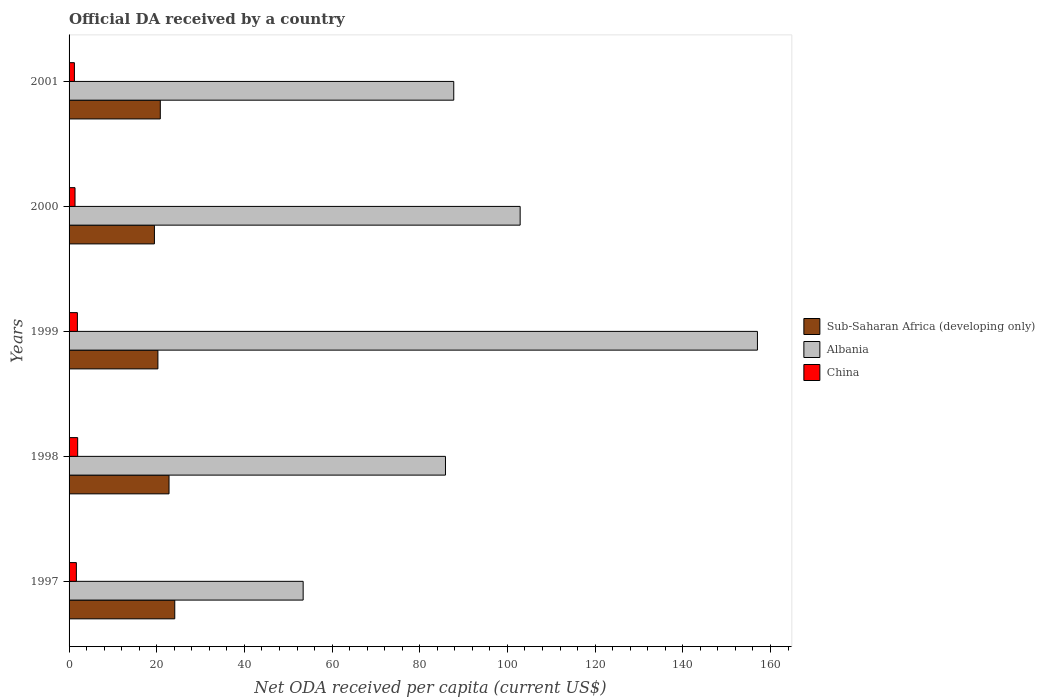How many different coloured bars are there?
Keep it short and to the point. 3. Are the number of bars per tick equal to the number of legend labels?
Make the answer very short. Yes. Are the number of bars on each tick of the Y-axis equal?
Ensure brevity in your answer.  Yes. How many bars are there on the 4th tick from the top?
Offer a terse response. 3. What is the label of the 1st group of bars from the top?
Your answer should be compact. 2001. What is the ODA received in in Sub-Saharan Africa (developing only) in 2000?
Offer a terse response. 19.47. Across all years, what is the maximum ODA received in in Albania?
Give a very brief answer. 157.02. Across all years, what is the minimum ODA received in in Albania?
Provide a short and direct response. 53.4. What is the total ODA received in in China in the graph?
Your answer should be compact. 8.1. What is the difference between the ODA received in in Sub-Saharan Africa (developing only) in 1997 and that in 1999?
Your answer should be compact. 3.84. What is the difference between the ODA received in in China in 1997 and the ODA received in in Sub-Saharan Africa (developing only) in 2001?
Make the answer very short. -19.15. What is the average ODA received in in China per year?
Provide a succinct answer. 1.62. In the year 1997, what is the difference between the ODA received in in Sub-Saharan Africa (developing only) and ODA received in in Albania?
Provide a short and direct response. -29.29. In how many years, is the ODA received in in Albania greater than 96 US$?
Keep it short and to the point. 2. What is the ratio of the ODA received in in China in 1997 to that in 2000?
Your answer should be very brief. 1.23. Is the difference between the ODA received in in Sub-Saharan Africa (developing only) in 1997 and 1998 greater than the difference between the ODA received in in Albania in 1997 and 1998?
Your response must be concise. Yes. What is the difference between the highest and the second highest ODA received in in China?
Offer a very short reply. 0.06. What is the difference between the highest and the lowest ODA received in in Albania?
Your answer should be compact. 103.63. In how many years, is the ODA received in in China greater than the average ODA received in in China taken over all years?
Your answer should be compact. 3. What does the 2nd bar from the top in 2001 represents?
Your answer should be compact. Albania. What does the 1st bar from the bottom in 2000 represents?
Provide a succinct answer. Sub-Saharan Africa (developing only). Is it the case that in every year, the sum of the ODA received in in Sub-Saharan Africa (developing only) and ODA received in in China is greater than the ODA received in in Albania?
Ensure brevity in your answer.  No. How many bars are there?
Make the answer very short. 15. What is the difference between two consecutive major ticks on the X-axis?
Your answer should be very brief. 20. Are the values on the major ticks of X-axis written in scientific E-notation?
Your answer should be very brief. No. Does the graph contain grids?
Provide a short and direct response. No. How are the legend labels stacked?
Give a very brief answer. Vertical. What is the title of the graph?
Your answer should be compact. Official DA received by a country. What is the label or title of the X-axis?
Keep it short and to the point. Net ODA received per capita (current US$). What is the label or title of the Y-axis?
Offer a terse response. Years. What is the Net ODA received per capita (current US$) in Sub-Saharan Africa (developing only) in 1997?
Your answer should be very brief. 24.11. What is the Net ODA received per capita (current US$) of Albania in 1997?
Offer a terse response. 53.4. What is the Net ODA received per capita (current US$) in China in 1997?
Offer a terse response. 1.66. What is the Net ODA received per capita (current US$) of Sub-Saharan Africa (developing only) in 1998?
Your answer should be compact. 22.8. What is the Net ODA received per capita (current US$) in Albania in 1998?
Give a very brief answer. 85.86. What is the Net ODA received per capita (current US$) of China in 1998?
Keep it short and to the point. 1.96. What is the Net ODA received per capita (current US$) in Sub-Saharan Africa (developing only) in 1999?
Keep it short and to the point. 20.27. What is the Net ODA received per capita (current US$) of Albania in 1999?
Offer a terse response. 157.02. What is the Net ODA received per capita (current US$) of China in 1999?
Offer a very short reply. 1.9. What is the Net ODA received per capita (current US$) in Sub-Saharan Africa (developing only) in 2000?
Your answer should be very brief. 19.47. What is the Net ODA received per capita (current US$) in Albania in 2000?
Give a very brief answer. 102.9. What is the Net ODA received per capita (current US$) in China in 2000?
Ensure brevity in your answer.  1.36. What is the Net ODA received per capita (current US$) of Sub-Saharan Africa (developing only) in 2001?
Keep it short and to the point. 20.81. What is the Net ODA received per capita (current US$) of Albania in 2001?
Make the answer very short. 87.75. What is the Net ODA received per capita (current US$) of China in 2001?
Ensure brevity in your answer.  1.22. Across all years, what is the maximum Net ODA received per capita (current US$) in Sub-Saharan Africa (developing only)?
Your answer should be compact. 24.11. Across all years, what is the maximum Net ODA received per capita (current US$) of Albania?
Your response must be concise. 157.02. Across all years, what is the maximum Net ODA received per capita (current US$) in China?
Provide a succinct answer. 1.96. Across all years, what is the minimum Net ODA received per capita (current US$) in Sub-Saharan Africa (developing only)?
Your answer should be compact. 19.47. Across all years, what is the minimum Net ODA received per capita (current US$) in Albania?
Offer a terse response. 53.4. Across all years, what is the minimum Net ODA received per capita (current US$) of China?
Keep it short and to the point. 1.22. What is the total Net ODA received per capita (current US$) of Sub-Saharan Africa (developing only) in the graph?
Your answer should be very brief. 107.46. What is the total Net ODA received per capita (current US$) in Albania in the graph?
Your response must be concise. 486.93. What is the total Net ODA received per capita (current US$) in China in the graph?
Your answer should be compact. 8.1. What is the difference between the Net ODA received per capita (current US$) of Sub-Saharan Africa (developing only) in 1997 and that in 1998?
Your answer should be compact. 1.31. What is the difference between the Net ODA received per capita (current US$) in Albania in 1997 and that in 1998?
Your response must be concise. -32.46. What is the difference between the Net ODA received per capita (current US$) in China in 1997 and that in 1998?
Provide a short and direct response. -0.3. What is the difference between the Net ODA received per capita (current US$) in Sub-Saharan Africa (developing only) in 1997 and that in 1999?
Provide a succinct answer. 3.84. What is the difference between the Net ODA received per capita (current US$) in Albania in 1997 and that in 1999?
Make the answer very short. -103.63. What is the difference between the Net ODA received per capita (current US$) of China in 1997 and that in 1999?
Offer a terse response. -0.23. What is the difference between the Net ODA received per capita (current US$) of Sub-Saharan Africa (developing only) in 1997 and that in 2000?
Your answer should be very brief. 4.64. What is the difference between the Net ODA received per capita (current US$) of Albania in 1997 and that in 2000?
Give a very brief answer. -49.5. What is the difference between the Net ODA received per capita (current US$) of China in 1997 and that in 2000?
Your response must be concise. 0.31. What is the difference between the Net ODA received per capita (current US$) in Sub-Saharan Africa (developing only) in 1997 and that in 2001?
Your response must be concise. 3.3. What is the difference between the Net ODA received per capita (current US$) in Albania in 1997 and that in 2001?
Keep it short and to the point. -34.35. What is the difference between the Net ODA received per capita (current US$) in China in 1997 and that in 2001?
Make the answer very short. 0.45. What is the difference between the Net ODA received per capita (current US$) in Sub-Saharan Africa (developing only) in 1998 and that in 1999?
Give a very brief answer. 2.54. What is the difference between the Net ODA received per capita (current US$) of Albania in 1998 and that in 1999?
Offer a very short reply. -71.16. What is the difference between the Net ODA received per capita (current US$) of China in 1998 and that in 1999?
Keep it short and to the point. 0.06. What is the difference between the Net ODA received per capita (current US$) of Sub-Saharan Africa (developing only) in 1998 and that in 2000?
Offer a very short reply. 3.33. What is the difference between the Net ODA received per capita (current US$) in Albania in 1998 and that in 2000?
Your response must be concise. -17.04. What is the difference between the Net ODA received per capita (current US$) of China in 1998 and that in 2000?
Offer a very short reply. 0.61. What is the difference between the Net ODA received per capita (current US$) of Sub-Saharan Africa (developing only) in 1998 and that in 2001?
Provide a succinct answer. 1.99. What is the difference between the Net ODA received per capita (current US$) of Albania in 1998 and that in 2001?
Provide a short and direct response. -1.89. What is the difference between the Net ODA received per capita (current US$) of China in 1998 and that in 2001?
Offer a very short reply. 0.75. What is the difference between the Net ODA received per capita (current US$) of Sub-Saharan Africa (developing only) in 1999 and that in 2000?
Your answer should be compact. 0.8. What is the difference between the Net ODA received per capita (current US$) of Albania in 1999 and that in 2000?
Keep it short and to the point. 54.13. What is the difference between the Net ODA received per capita (current US$) of China in 1999 and that in 2000?
Keep it short and to the point. 0.54. What is the difference between the Net ODA received per capita (current US$) of Sub-Saharan Africa (developing only) in 1999 and that in 2001?
Ensure brevity in your answer.  -0.55. What is the difference between the Net ODA received per capita (current US$) of Albania in 1999 and that in 2001?
Offer a very short reply. 69.27. What is the difference between the Net ODA received per capita (current US$) of China in 1999 and that in 2001?
Provide a succinct answer. 0.68. What is the difference between the Net ODA received per capita (current US$) of Sub-Saharan Africa (developing only) in 2000 and that in 2001?
Provide a succinct answer. -1.34. What is the difference between the Net ODA received per capita (current US$) in Albania in 2000 and that in 2001?
Your answer should be compact. 15.15. What is the difference between the Net ODA received per capita (current US$) of China in 2000 and that in 2001?
Make the answer very short. 0.14. What is the difference between the Net ODA received per capita (current US$) of Sub-Saharan Africa (developing only) in 1997 and the Net ODA received per capita (current US$) of Albania in 1998?
Provide a succinct answer. -61.75. What is the difference between the Net ODA received per capita (current US$) in Sub-Saharan Africa (developing only) in 1997 and the Net ODA received per capita (current US$) in China in 1998?
Provide a short and direct response. 22.15. What is the difference between the Net ODA received per capita (current US$) of Albania in 1997 and the Net ODA received per capita (current US$) of China in 1998?
Provide a succinct answer. 51.43. What is the difference between the Net ODA received per capita (current US$) in Sub-Saharan Africa (developing only) in 1997 and the Net ODA received per capita (current US$) in Albania in 1999?
Keep it short and to the point. -132.91. What is the difference between the Net ODA received per capita (current US$) of Sub-Saharan Africa (developing only) in 1997 and the Net ODA received per capita (current US$) of China in 1999?
Your response must be concise. 22.21. What is the difference between the Net ODA received per capita (current US$) of Albania in 1997 and the Net ODA received per capita (current US$) of China in 1999?
Keep it short and to the point. 51.5. What is the difference between the Net ODA received per capita (current US$) of Sub-Saharan Africa (developing only) in 1997 and the Net ODA received per capita (current US$) of Albania in 2000?
Offer a terse response. -78.79. What is the difference between the Net ODA received per capita (current US$) of Sub-Saharan Africa (developing only) in 1997 and the Net ODA received per capita (current US$) of China in 2000?
Make the answer very short. 22.75. What is the difference between the Net ODA received per capita (current US$) in Albania in 1997 and the Net ODA received per capita (current US$) in China in 2000?
Provide a short and direct response. 52.04. What is the difference between the Net ODA received per capita (current US$) of Sub-Saharan Africa (developing only) in 1997 and the Net ODA received per capita (current US$) of Albania in 2001?
Give a very brief answer. -63.64. What is the difference between the Net ODA received per capita (current US$) of Sub-Saharan Africa (developing only) in 1997 and the Net ODA received per capita (current US$) of China in 2001?
Your answer should be very brief. 22.89. What is the difference between the Net ODA received per capita (current US$) in Albania in 1997 and the Net ODA received per capita (current US$) in China in 2001?
Keep it short and to the point. 52.18. What is the difference between the Net ODA received per capita (current US$) in Sub-Saharan Africa (developing only) in 1998 and the Net ODA received per capita (current US$) in Albania in 1999?
Ensure brevity in your answer.  -134.22. What is the difference between the Net ODA received per capita (current US$) of Sub-Saharan Africa (developing only) in 1998 and the Net ODA received per capita (current US$) of China in 1999?
Offer a terse response. 20.9. What is the difference between the Net ODA received per capita (current US$) in Albania in 1998 and the Net ODA received per capita (current US$) in China in 1999?
Your answer should be very brief. 83.96. What is the difference between the Net ODA received per capita (current US$) of Sub-Saharan Africa (developing only) in 1998 and the Net ODA received per capita (current US$) of Albania in 2000?
Ensure brevity in your answer.  -80.1. What is the difference between the Net ODA received per capita (current US$) in Sub-Saharan Africa (developing only) in 1998 and the Net ODA received per capita (current US$) in China in 2000?
Your answer should be very brief. 21.45. What is the difference between the Net ODA received per capita (current US$) of Albania in 1998 and the Net ODA received per capita (current US$) of China in 2000?
Ensure brevity in your answer.  84.51. What is the difference between the Net ODA received per capita (current US$) of Sub-Saharan Africa (developing only) in 1998 and the Net ODA received per capita (current US$) of Albania in 2001?
Your answer should be very brief. -64.95. What is the difference between the Net ODA received per capita (current US$) of Sub-Saharan Africa (developing only) in 1998 and the Net ODA received per capita (current US$) of China in 2001?
Your response must be concise. 21.58. What is the difference between the Net ODA received per capita (current US$) of Albania in 1998 and the Net ODA received per capita (current US$) of China in 2001?
Provide a succinct answer. 84.64. What is the difference between the Net ODA received per capita (current US$) in Sub-Saharan Africa (developing only) in 1999 and the Net ODA received per capita (current US$) in Albania in 2000?
Give a very brief answer. -82.63. What is the difference between the Net ODA received per capita (current US$) of Sub-Saharan Africa (developing only) in 1999 and the Net ODA received per capita (current US$) of China in 2000?
Provide a short and direct response. 18.91. What is the difference between the Net ODA received per capita (current US$) in Albania in 1999 and the Net ODA received per capita (current US$) in China in 2000?
Give a very brief answer. 155.67. What is the difference between the Net ODA received per capita (current US$) in Sub-Saharan Africa (developing only) in 1999 and the Net ODA received per capita (current US$) in Albania in 2001?
Your answer should be very brief. -67.48. What is the difference between the Net ODA received per capita (current US$) in Sub-Saharan Africa (developing only) in 1999 and the Net ODA received per capita (current US$) in China in 2001?
Offer a very short reply. 19.05. What is the difference between the Net ODA received per capita (current US$) of Albania in 1999 and the Net ODA received per capita (current US$) of China in 2001?
Your answer should be very brief. 155.81. What is the difference between the Net ODA received per capita (current US$) in Sub-Saharan Africa (developing only) in 2000 and the Net ODA received per capita (current US$) in Albania in 2001?
Offer a very short reply. -68.28. What is the difference between the Net ODA received per capita (current US$) in Sub-Saharan Africa (developing only) in 2000 and the Net ODA received per capita (current US$) in China in 2001?
Provide a succinct answer. 18.25. What is the difference between the Net ODA received per capita (current US$) of Albania in 2000 and the Net ODA received per capita (current US$) of China in 2001?
Ensure brevity in your answer.  101.68. What is the average Net ODA received per capita (current US$) of Sub-Saharan Africa (developing only) per year?
Offer a very short reply. 21.49. What is the average Net ODA received per capita (current US$) of Albania per year?
Your response must be concise. 97.39. What is the average Net ODA received per capita (current US$) in China per year?
Offer a very short reply. 1.62. In the year 1997, what is the difference between the Net ODA received per capita (current US$) of Sub-Saharan Africa (developing only) and Net ODA received per capita (current US$) of Albania?
Provide a short and direct response. -29.29. In the year 1997, what is the difference between the Net ODA received per capita (current US$) of Sub-Saharan Africa (developing only) and Net ODA received per capita (current US$) of China?
Make the answer very short. 22.44. In the year 1997, what is the difference between the Net ODA received per capita (current US$) in Albania and Net ODA received per capita (current US$) in China?
Provide a succinct answer. 51.73. In the year 1998, what is the difference between the Net ODA received per capita (current US$) in Sub-Saharan Africa (developing only) and Net ODA received per capita (current US$) in Albania?
Provide a succinct answer. -63.06. In the year 1998, what is the difference between the Net ODA received per capita (current US$) of Sub-Saharan Africa (developing only) and Net ODA received per capita (current US$) of China?
Your answer should be very brief. 20.84. In the year 1998, what is the difference between the Net ODA received per capita (current US$) of Albania and Net ODA received per capita (current US$) of China?
Offer a very short reply. 83.9. In the year 1999, what is the difference between the Net ODA received per capita (current US$) in Sub-Saharan Africa (developing only) and Net ODA received per capita (current US$) in Albania?
Give a very brief answer. -136.76. In the year 1999, what is the difference between the Net ODA received per capita (current US$) of Sub-Saharan Africa (developing only) and Net ODA received per capita (current US$) of China?
Offer a terse response. 18.37. In the year 1999, what is the difference between the Net ODA received per capita (current US$) of Albania and Net ODA received per capita (current US$) of China?
Your response must be concise. 155.12. In the year 2000, what is the difference between the Net ODA received per capita (current US$) of Sub-Saharan Africa (developing only) and Net ODA received per capita (current US$) of Albania?
Make the answer very short. -83.43. In the year 2000, what is the difference between the Net ODA received per capita (current US$) in Sub-Saharan Africa (developing only) and Net ODA received per capita (current US$) in China?
Ensure brevity in your answer.  18.11. In the year 2000, what is the difference between the Net ODA received per capita (current US$) in Albania and Net ODA received per capita (current US$) in China?
Offer a very short reply. 101.54. In the year 2001, what is the difference between the Net ODA received per capita (current US$) in Sub-Saharan Africa (developing only) and Net ODA received per capita (current US$) in Albania?
Your response must be concise. -66.94. In the year 2001, what is the difference between the Net ODA received per capita (current US$) in Sub-Saharan Africa (developing only) and Net ODA received per capita (current US$) in China?
Ensure brevity in your answer.  19.59. In the year 2001, what is the difference between the Net ODA received per capita (current US$) in Albania and Net ODA received per capita (current US$) in China?
Provide a succinct answer. 86.53. What is the ratio of the Net ODA received per capita (current US$) in Sub-Saharan Africa (developing only) in 1997 to that in 1998?
Your answer should be very brief. 1.06. What is the ratio of the Net ODA received per capita (current US$) in Albania in 1997 to that in 1998?
Your answer should be very brief. 0.62. What is the ratio of the Net ODA received per capita (current US$) of China in 1997 to that in 1998?
Provide a succinct answer. 0.85. What is the ratio of the Net ODA received per capita (current US$) in Sub-Saharan Africa (developing only) in 1997 to that in 1999?
Give a very brief answer. 1.19. What is the ratio of the Net ODA received per capita (current US$) in Albania in 1997 to that in 1999?
Keep it short and to the point. 0.34. What is the ratio of the Net ODA received per capita (current US$) of China in 1997 to that in 1999?
Keep it short and to the point. 0.88. What is the ratio of the Net ODA received per capita (current US$) in Sub-Saharan Africa (developing only) in 1997 to that in 2000?
Your answer should be very brief. 1.24. What is the ratio of the Net ODA received per capita (current US$) in Albania in 1997 to that in 2000?
Make the answer very short. 0.52. What is the ratio of the Net ODA received per capita (current US$) of China in 1997 to that in 2000?
Your answer should be compact. 1.23. What is the ratio of the Net ODA received per capita (current US$) of Sub-Saharan Africa (developing only) in 1997 to that in 2001?
Offer a terse response. 1.16. What is the ratio of the Net ODA received per capita (current US$) in Albania in 1997 to that in 2001?
Make the answer very short. 0.61. What is the ratio of the Net ODA received per capita (current US$) of China in 1997 to that in 2001?
Offer a very short reply. 1.37. What is the ratio of the Net ODA received per capita (current US$) in Sub-Saharan Africa (developing only) in 1998 to that in 1999?
Provide a short and direct response. 1.13. What is the ratio of the Net ODA received per capita (current US$) of Albania in 1998 to that in 1999?
Your answer should be compact. 0.55. What is the ratio of the Net ODA received per capita (current US$) of China in 1998 to that in 1999?
Your response must be concise. 1.03. What is the ratio of the Net ODA received per capita (current US$) in Sub-Saharan Africa (developing only) in 1998 to that in 2000?
Offer a very short reply. 1.17. What is the ratio of the Net ODA received per capita (current US$) of Albania in 1998 to that in 2000?
Your response must be concise. 0.83. What is the ratio of the Net ODA received per capita (current US$) of China in 1998 to that in 2000?
Provide a short and direct response. 1.45. What is the ratio of the Net ODA received per capita (current US$) of Sub-Saharan Africa (developing only) in 1998 to that in 2001?
Your response must be concise. 1.1. What is the ratio of the Net ODA received per capita (current US$) of Albania in 1998 to that in 2001?
Ensure brevity in your answer.  0.98. What is the ratio of the Net ODA received per capita (current US$) in China in 1998 to that in 2001?
Give a very brief answer. 1.61. What is the ratio of the Net ODA received per capita (current US$) of Sub-Saharan Africa (developing only) in 1999 to that in 2000?
Your answer should be compact. 1.04. What is the ratio of the Net ODA received per capita (current US$) in Albania in 1999 to that in 2000?
Make the answer very short. 1.53. What is the ratio of the Net ODA received per capita (current US$) of China in 1999 to that in 2000?
Provide a succinct answer. 1.4. What is the ratio of the Net ODA received per capita (current US$) in Sub-Saharan Africa (developing only) in 1999 to that in 2001?
Ensure brevity in your answer.  0.97. What is the ratio of the Net ODA received per capita (current US$) of Albania in 1999 to that in 2001?
Your answer should be very brief. 1.79. What is the ratio of the Net ODA received per capita (current US$) of China in 1999 to that in 2001?
Make the answer very short. 1.56. What is the ratio of the Net ODA received per capita (current US$) of Sub-Saharan Africa (developing only) in 2000 to that in 2001?
Your response must be concise. 0.94. What is the ratio of the Net ODA received per capita (current US$) in Albania in 2000 to that in 2001?
Your answer should be compact. 1.17. What is the ratio of the Net ODA received per capita (current US$) of China in 2000 to that in 2001?
Offer a terse response. 1.11. What is the difference between the highest and the second highest Net ODA received per capita (current US$) in Sub-Saharan Africa (developing only)?
Your response must be concise. 1.31. What is the difference between the highest and the second highest Net ODA received per capita (current US$) of Albania?
Your answer should be very brief. 54.13. What is the difference between the highest and the second highest Net ODA received per capita (current US$) of China?
Provide a short and direct response. 0.06. What is the difference between the highest and the lowest Net ODA received per capita (current US$) in Sub-Saharan Africa (developing only)?
Provide a short and direct response. 4.64. What is the difference between the highest and the lowest Net ODA received per capita (current US$) of Albania?
Your answer should be compact. 103.63. What is the difference between the highest and the lowest Net ODA received per capita (current US$) in China?
Offer a very short reply. 0.75. 